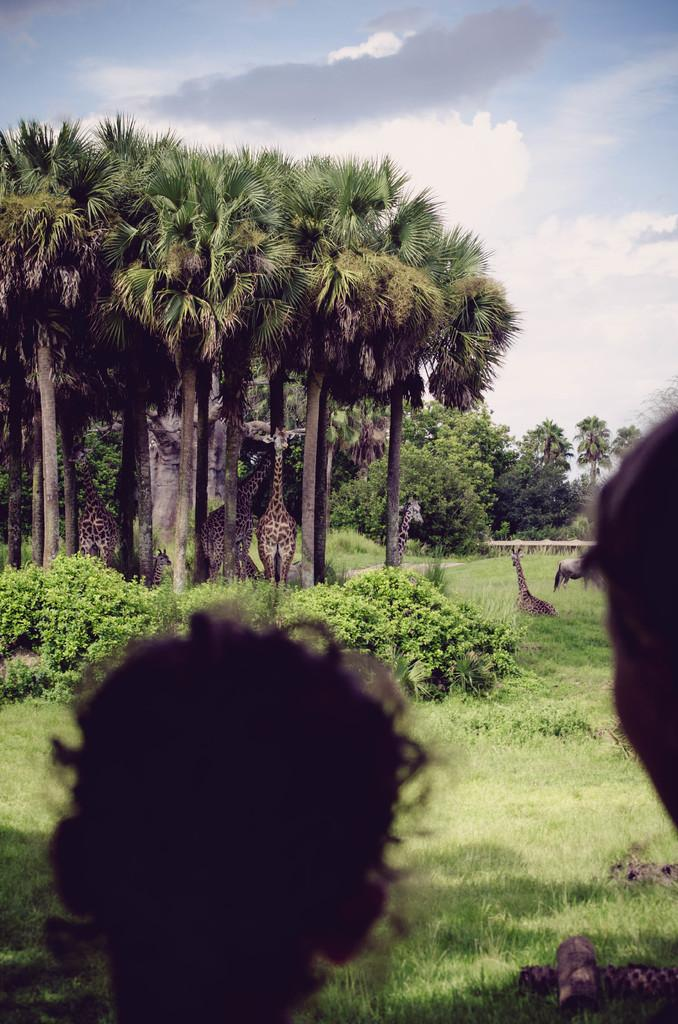How many persons' heads can be seen in the image? There are two persons' heads visible in the image. What animals are present in the image? There are giraffes in the image. What type of vegetation is visible in the image? There is grass, plants, and trees in the image. What can be seen in the background of the image? The sky is visible in the background of the image. How does the credit affect the image? There is no mention of credit in the image, so it cannot affect the image. 